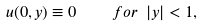<formula> <loc_0><loc_0><loc_500><loc_500>u ( 0 , y ) \equiv 0 \quad f o r \ | y | < 1 ,</formula> 